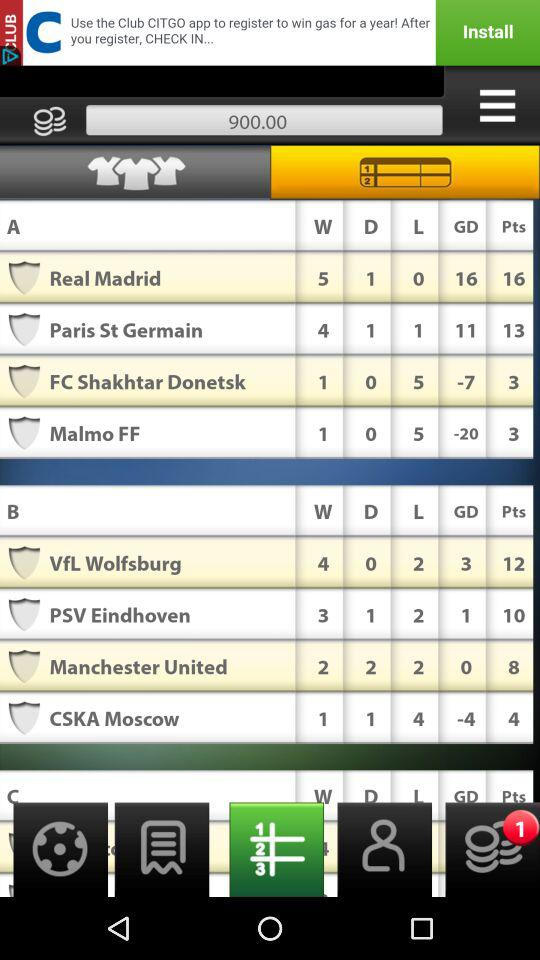What is the tally point for Manchester United? The tally point for Manchester United's is 8. 